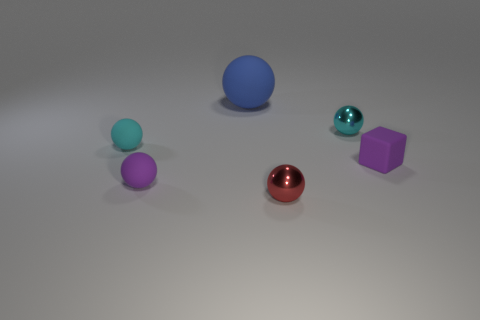There is a purple sphere; are there any metallic objects in front of it?
Your answer should be compact. Yes. Are the tiny purple object that is to the left of the large matte object and the cyan sphere on the left side of the big blue rubber sphere made of the same material?
Provide a succinct answer. Yes. What number of blue matte objects have the same size as the blue sphere?
Offer a very short reply. 0. What is the shape of the small matte object that is the same color as the tiny matte block?
Your answer should be very brief. Sphere. There is a tiny cyan ball right of the blue rubber thing; what is it made of?
Keep it short and to the point. Metal. What number of other blue things have the same shape as the blue rubber object?
Offer a terse response. 0. The blue thing that is made of the same material as the tiny purple block is what shape?
Keep it short and to the point. Sphere. What shape is the cyan shiny object that is to the right of the matte object behind the small rubber sphere on the left side of the purple matte sphere?
Your response must be concise. Sphere. Is the number of big blue spheres greater than the number of small gray rubber cylinders?
Provide a short and direct response. Yes. What is the material of the other cyan thing that is the same shape as the small cyan metallic thing?
Provide a succinct answer. Rubber. 